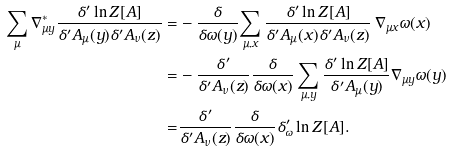<formula> <loc_0><loc_0><loc_500><loc_500>\sum _ { \mu } \nabla ^ { \ast } _ { \mu y } \frac { \delta ^ { \prime } \ln Z [ A ] } { \delta ^ { \prime } A _ { \mu } ( y ) \delta ^ { \prime } A _ { \nu } ( z ) } = & - \frac { \delta } { \delta \omega ( y ) } { \sum _ { \mu , x } \frac { \delta ^ { \prime } \ln Z [ A ] } { \delta ^ { \prime } A _ { \mu } ( x ) \delta ^ { \prime } A _ { \nu } ( z ) } } \, \nabla _ { \mu x } \omega ( x ) \\ = & - \frac { \delta ^ { \prime } } { \delta ^ { \prime } A _ { \nu } ( z ) } \frac { \delta } { \delta \omega ( x ) } \sum _ { \mu , y } \frac { \delta ^ { \prime } \ln Z [ A ] } { \delta ^ { \prime } A _ { \mu } ( y ) } \nabla _ { \mu y } \omega ( y ) \\ = & \frac { \delta ^ { \prime } } { \delta ^ { \prime } A _ { \nu } ( z ) } \frac { \delta } { \delta \omega ( x ) } \delta ^ { \prime } _ { \omega } \ln Z [ A ] .</formula> 